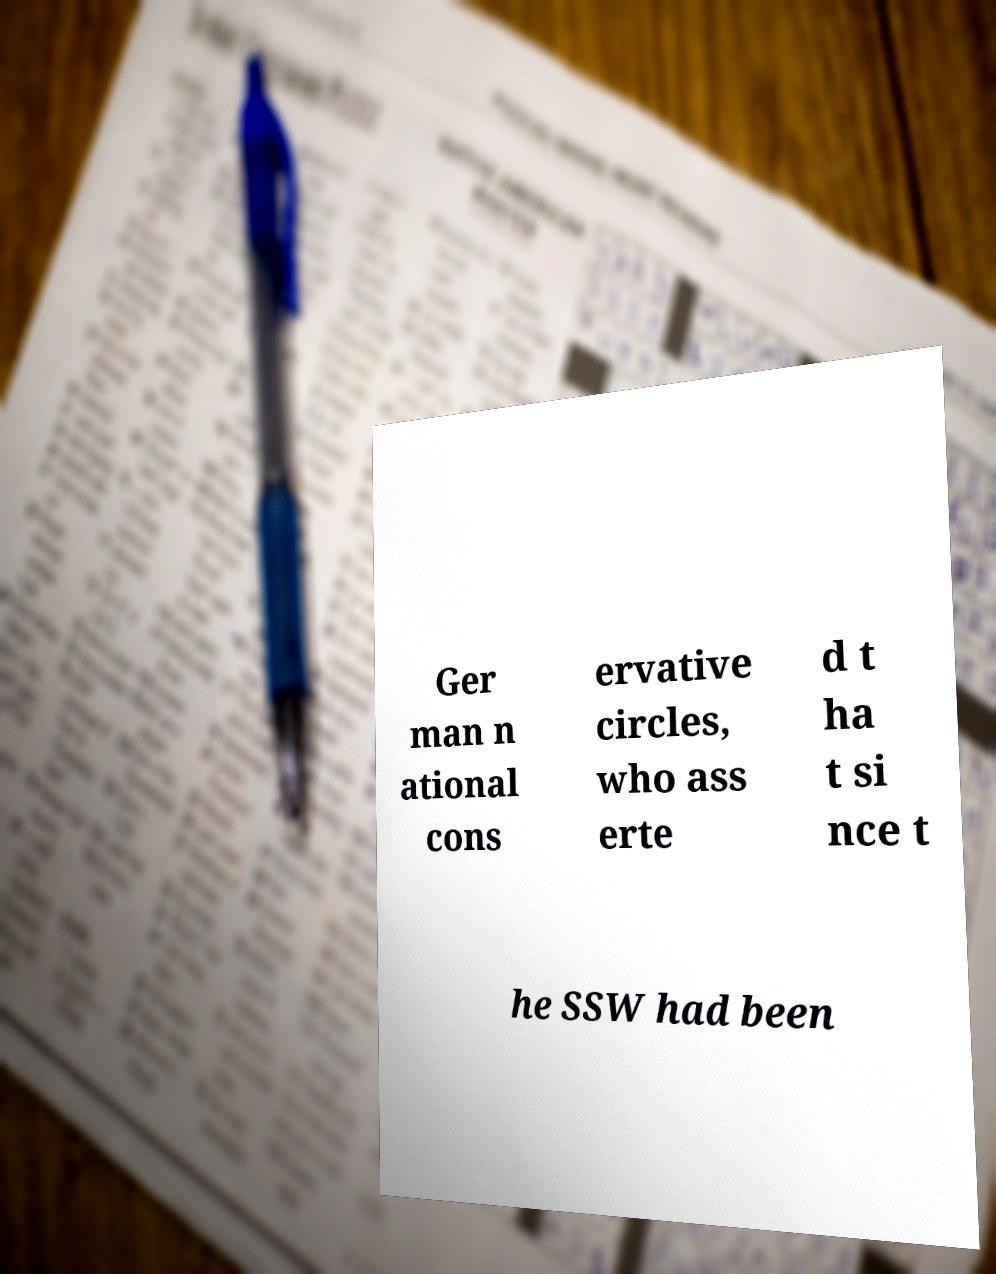Can you read and provide the text displayed in the image?This photo seems to have some interesting text. Can you extract and type it out for me? Ger man n ational cons ervative circles, who ass erte d t ha t si nce t he SSW had been 